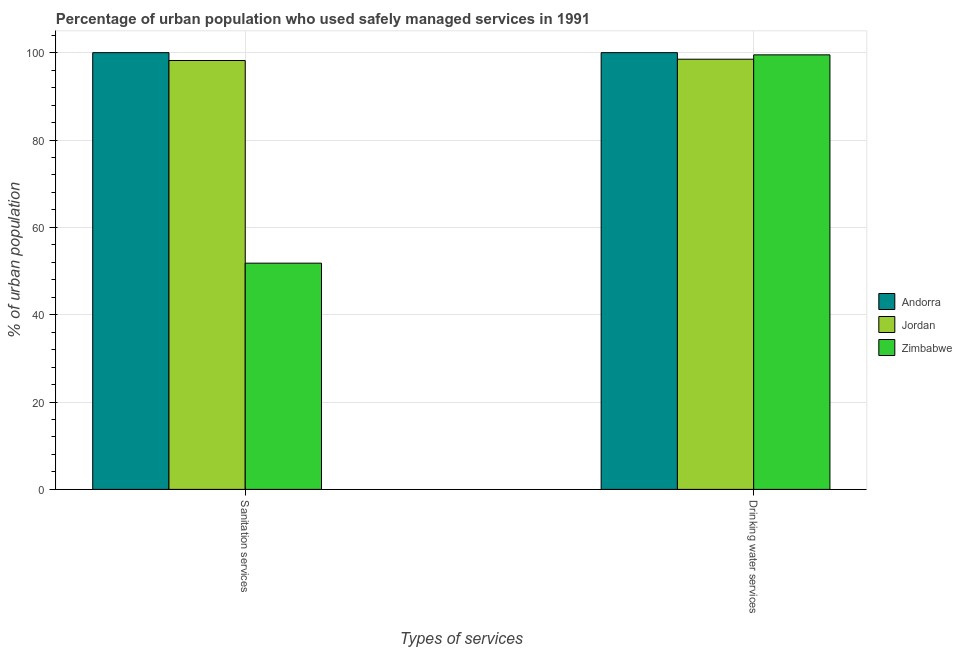How many groups of bars are there?
Your answer should be very brief. 2. Are the number of bars per tick equal to the number of legend labels?
Provide a succinct answer. Yes. Are the number of bars on each tick of the X-axis equal?
Your answer should be very brief. Yes. How many bars are there on the 2nd tick from the left?
Give a very brief answer. 3. How many bars are there on the 1st tick from the right?
Your response must be concise. 3. What is the label of the 1st group of bars from the left?
Keep it short and to the point. Sanitation services. What is the percentage of urban population who used sanitation services in Zimbabwe?
Your answer should be compact. 51.8. Across all countries, what is the minimum percentage of urban population who used drinking water services?
Your answer should be compact. 98.5. In which country was the percentage of urban population who used sanitation services maximum?
Your answer should be very brief. Andorra. In which country was the percentage of urban population who used sanitation services minimum?
Ensure brevity in your answer.  Zimbabwe. What is the total percentage of urban population who used drinking water services in the graph?
Offer a very short reply. 298. What is the difference between the percentage of urban population who used sanitation services in Jordan and that in Andorra?
Your answer should be very brief. -1.8. What is the difference between the percentage of urban population who used drinking water services in Jordan and the percentage of urban population who used sanitation services in Zimbabwe?
Give a very brief answer. 46.7. What is the average percentage of urban population who used drinking water services per country?
Make the answer very short. 99.33. What is the difference between the percentage of urban population who used sanitation services and percentage of urban population who used drinking water services in Jordan?
Keep it short and to the point. -0.3. What is the ratio of the percentage of urban population who used sanitation services in Zimbabwe to that in Andorra?
Provide a short and direct response. 0.52. In how many countries, is the percentage of urban population who used sanitation services greater than the average percentage of urban population who used sanitation services taken over all countries?
Make the answer very short. 2. What does the 2nd bar from the left in Sanitation services represents?
Give a very brief answer. Jordan. What does the 2nd bar from the right in Sanitation services represents?
Provide a succinct answer. Jordan. How many bars are there?
Your answer should be compact. 6. Are all the bars in the graph horizontal?
Provide a succinct answer. No. How many countries are there in the graph?
Offer a terse response. 3. What is the title of the graph?
Provide a succinct answer. Percentage of urban population who used safely managed services in 1991. Does "Middle East & North Africa (developing only)" appear as one of the legend labels in the graph?
Make the answer very short. No. What is the label or title of the X-axis?
Ensure brevity in your answer.  Types of services. What is the label or title of the Y-axis?
Provide a short and direct response. % of urban population. What is the % of urban population of Andorra in Sanitation services?
Provide a short and direct response. 100. What is the % of urban population in Jordan in Sanitation services?
Provide a short and direct response. 98.2. What is the % of urban population of Zimbabwe in Sanitation services?
Provide a succinct answer. 51.8. What is the % of urban population in Andorra in Drinking water services?
Keep it short and to the point. 100. What is the % of urban population of Jordan in Drinking water services?
Your answer should be compact. 98.5. What is the % of urban population in Zimbabwe in Drinking water services?
Make the answer very short. 99.5. Across all Types of services, what is the maximum % of urban population of Jordan?
Offer a terse response. 98.5. Across all Types of services, what is the maximum % of urban population in Zimbabwe?
Offer a very short reply. 99.5. Across all Types of services, what is the minimum % of urban population of Jordan?
Keep it short and to the point. 98.2. Across all Types of services, what is the minimum % of urban population in Zimbabwe?
Provide a succinct answer. 51.8. What is the total % of urban population of Andorra in the graph?
Give a very brief answer. 200. What is the total % of urban population in Jordan in the graph?
Give a very brief answer. 196.7. What is the total % of urban population in Zimbabwe in the graph?
Keep it short and to the point. 151.3. What is the difference between the % of urban population of Andorra in Sanitation services and that in Drinking water services?
Make the answer very short. 0. What is the difference between the % of urban population in Zimbabwe in Sanitation services and that in Drinking water services?
Provide a succinct answer. -47.7. What is the difference between the % of urban population of Andorra in Sanitation services and the % of urban population of Jordan in Drinking water services?
Provide a succinct answer. 1.5. What is the difference between the % of urban population in Andorra in Sanitation services and the % of urban population in Zimbabwe in Drinking water services?
Your answer should be very brief. 0.5. What is the difference between the % of urban population of Jordan in Sanitation services and the % of urban population of Zimbabwe in Drinking water services?
Your response must be concise. -1.3. What is the average % of urban population of Jordan per Types of services?
Your response must be concise. 98.35. What is the average % of urban population in Zimbabwe per Types of services?
Give a very brief answer. 75.65. What is the difference between the % of urban population in Andorra and % of urban population in Zimbabwe in Sanitation services?
Make the answer very short. 48.2. What is the difference between the % of urban population in Jordan and % of urban population in Zimbabwe in Sanitation services?
Keep it short and to the point. 46.4. What is the difference between the % of urban population of Andorra and % of urban population of Jordan in Drinking water services?
Give a very brief answer. 1.5. What is the difference between the % of urban population in Andorra and % of urban population in Zimbabwe in Drinking water services?
Offer a very short reply. 0.5. What is the difference between the % of urban population of Jordan and % of urban population of Zimbabwe in Drinking water services?
Provide a succinct answer. -1. What is the ratio of the % of urban population of Jordan in Sanitation services to that in Drinking water services?
Your response must be concise. 1. What is the ratio of the % of urban population in Zimbabwe in Sanitation services to that in Drinking water services?
Offer a very short reply. 0.52. What is the difference between the highest and the second highest % of urban population in Jordan?
Give a very brief answer. 0.3. What is the difference between the highest and the second highest % of urban population of Zimbabwe?
Offer a terse response. 47.7. What is the difference between the highest and the lowest % of urban population of Zimbabwe?
Provide a succinct answer. 47.7. 